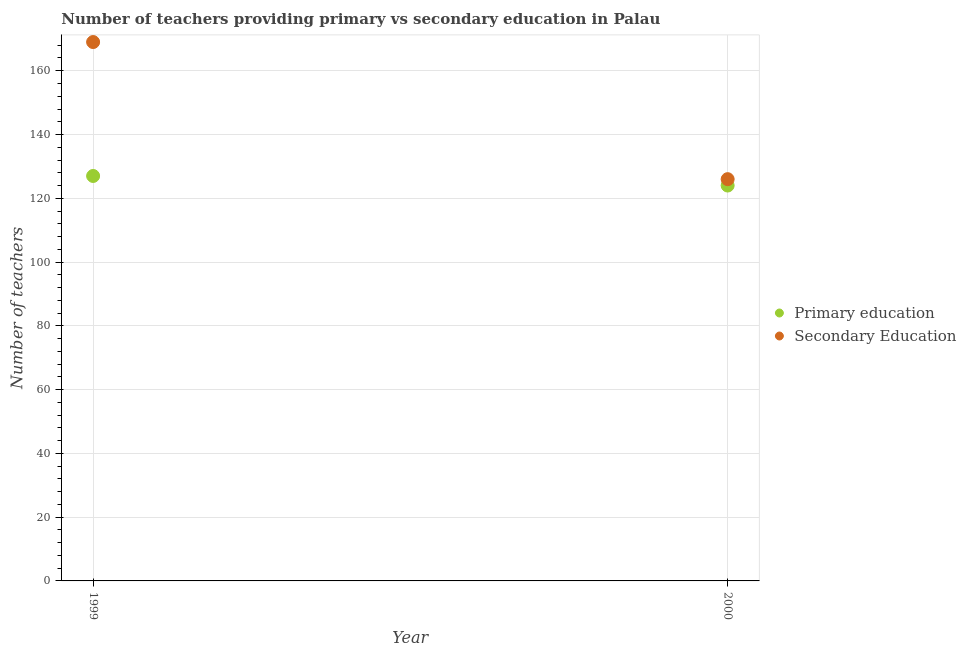Is the number of dotlines equal to the number of legend labels?
Give a very brief answer. Yes. What is the number of secondary teachers in 2000?
Keep it short and to the point. 126. Across all years, what is the maximum number of primary teachers?
Make the answer very short. 127. Across all years, what is the minimum number of secondary teachers?
Keep it short and to the point. 126. In which year was the number of secondary teachers maximum?
Provide a succinct answer. 1999. In which year was the number of secondary teachers minimum?
Ensure brevity in your answer.  2000. What is the total number of primary teachers in the graph?
Keep it short and to the point. 251. What is the difference between the number of primary teachers in 1999 and that in 2000?
Ensure brevity in your answer.  3. What is the difference between the number of secondary teachers in 1999 and the number of primary teachers in 2000?
Provide a short and direct response. 45. What is the average number of secondary teachers per year?
Offer a terse response. 147.5. In the year 1999, what is the difference between the number of primary teachers and number of secondary teachers?
Give a very brief answer. -42. In how many years, is the number of secondary teachers greater than 132?
Ensure brevity in your answer.  1. What is the ratio of the number of primary teachers in 1999 to that in 2000?
Provide a succinct answer. 1.02. Is the number of primary teachers in 1999 less than that in 2000?
Give a very brief answer. No. In how many years, is the number of secondary teachers greater than the average number of secondary teachers taken over all years?
Your response must be concise. 1. Is the number of secondary teachers strictly less than the number of primary teachers over the years?
Your response must be concise. No. How many years are there in the graph?
Ensure brevity in your answer.  2. Are the values on the major ticks of Y-axis written in scientific E-notation?
Your response must be concise. No. Does the graph contain any zero values?
Keep it short and to the point. No. Does the graph contain grids?
Make the answer very short. Yes. Where does the legend appear in the graph?
Provide a short and direct response. Center right. What is the title of the graph?
Offer a very short reply. Number of teachers providing primary vs secondary education in Palau. What is the label or title of the Y-axis?
Offer a terse response. Number of teachers. What is the Number of teachers in Primary education in 1999?
Keep it short and to the point. 127. What is the Number of teachers in Secondary Education in 1999?
Your response must be concise. 169. What is the Number of teachers in Primary education in 2000?
Make the answer very short. 124. What is the Number of teachers in Secondary Education in 2000?
Your answer should be compact. 126. Across all years, what is the maximum Number of teachers of Primary education?
Offer a very short reply. 127. Across all years, what is the maximum Number of teachers in Secondary Education?
Offer a very short reply. 169. Across all years, what is the minimum Number of teachers of Primary education?
Offer a very short reply. 124. Across all years, what is the minimum Number of teachers of Secondary Education?
Provide a short and direct response. 126. What is the total Number of teachers in Primary education in the graph?
Offer a terse response. 251. What is the total Number of teachers in Secondary Education in the graph?
Your answer should be very brief. 295. What is the average Number of teachers of Primary education per year?
Give a very brief answer. 125.5. What is the average Number of teachers in Secondary Education per year?
Make the answer very short. 147.5. In the year 1999, what is the difference between the Number of teachers in Primary education and Number of teachers in Secondary Education?
Your answer should be compact. -42. What is the ratio of the Number of teachers of Primary education in 1999 to that in 2000?
Your answer should be compact. 1.02. What is the ratio of the Number of teachers of Secondary Education in 1999 to that in 2000?
Your answer should be compact. 1.34. What is the difference between the highest and the second highest Number of teachers in Secondary Education?
Offer a terse response. 43. 